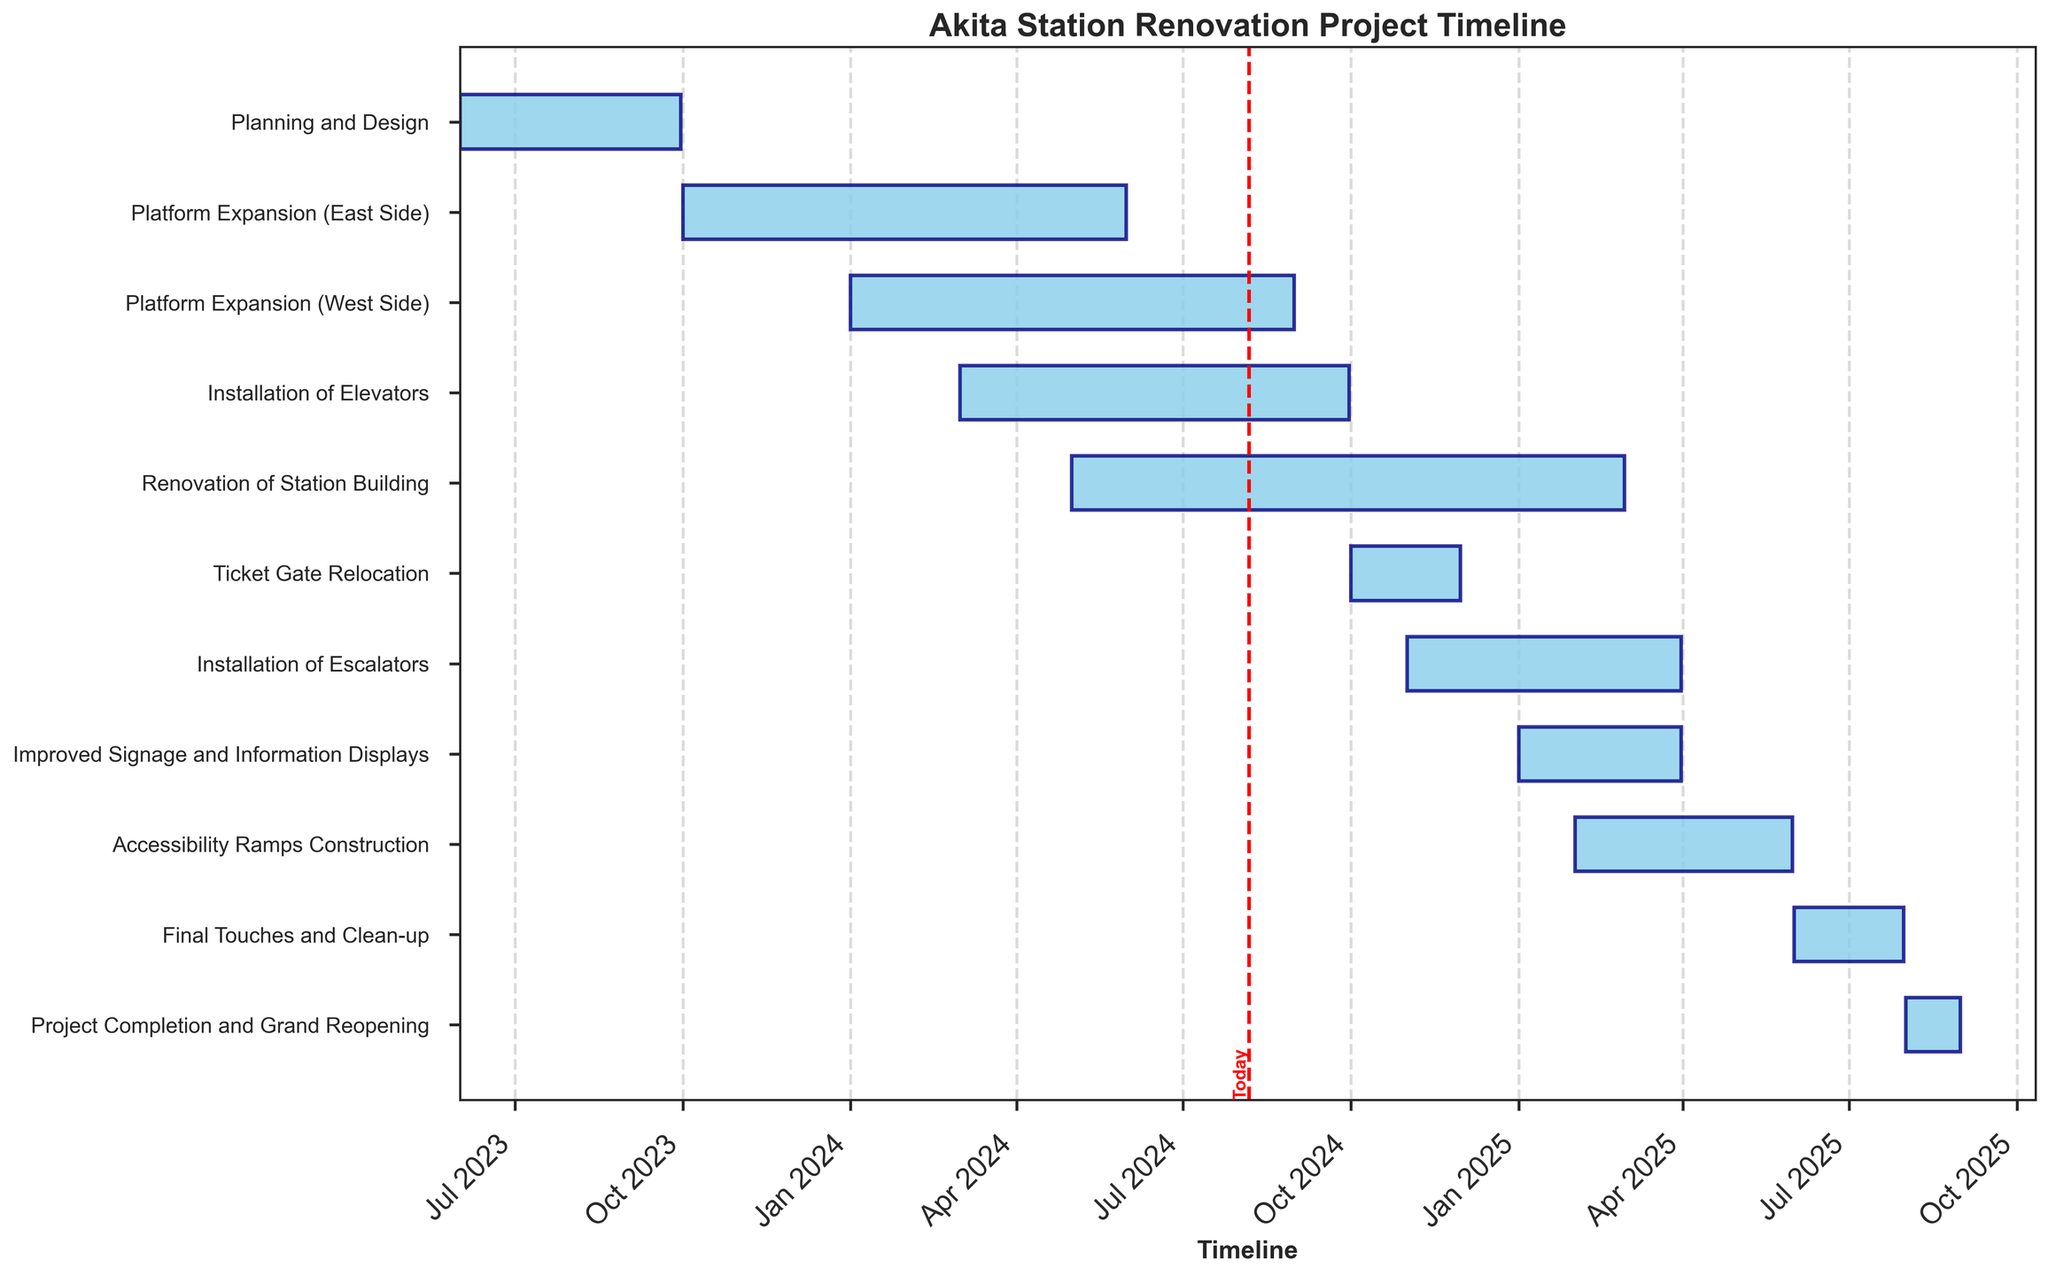What is the title of the figure? The title is at the top of the figure, usually in larger and bold text, indicating it summarizes the chart's content.
Answer: Akita Station Renovation Project Timeline When does the Installation of Elevators task begin and end? Look for the "Installation of Elevators" task label on the y-axis, then find the corresponding bar and note its start and end dates.
Answer: 2024-03-01 to 2024-09-30 How long is the Planning and Design phase? Calculate the duration by taking the difference between the end and start dates for the Planning and Design phase.
Answer: 121 days Which task starts first, Platform Expansion (West Side) or Installation of Escalators? Compare the start dates of both tasks to determine which one commences earlier.
Answer: Platform Expansion (West Side) How many tasks are scheduled to be in progress by January 2025? Identify tasks that overlap with January 2025 by looking at their start and end dates, count these tasks.
Answer: Four What is the duration of the Project Completion and Grand Reopening phase? Determine the duration by subtracting the start date from the end date for the Project Completion and Grand Reopening phase.
Answer: 30 days Which task has the longest duration, and what is it? Calculate the duration for each task and compare them to identify the longest one.
Answer: Renovation of Station Building How many tasks are scheduled to happen simultaneously in April 2024? Identify tasks whose durations overlap with April 2024 and count them.
Answer: Three Do any tasks overlap with the Platform Expansion (East Side) task? If so, which ones? Look at the start and end dates of the Platform Expansion (East Side) and check for overlapping periods with other tasks.
Answer: Platform Expansion (West Side) and Installation of Elevators 